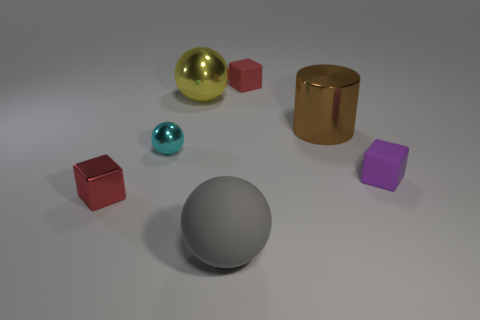Add 1 yellow metal things. How many objects exist? 8 Subtract all cylinders. How many objects are left? 6 Add 5 yellow shiny objects. How many yellow shiny objects are left? 6 Add 6 blue metallic things. How many blue metallic things exist? 6 Subtract 0 red cylinders. How many objects are left? 7 Subtract all tiny cyan matte blocks. Subtract all small purple objects. How many objects are left? 6 